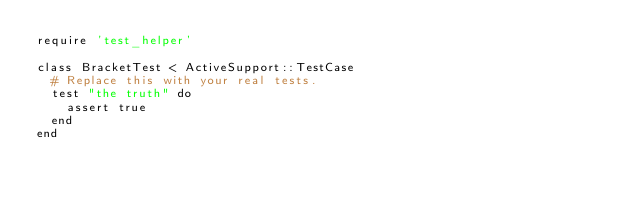<code> <loc_0><loc_0><loc_500><loc_500><_Ruby_>require 'test_helper'

class BracketTest < ActiveSupport::TestCase
  # Replace this with your real tests.
  test "the truth" do
    assert true
  end
end
</code> 